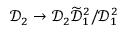Convert formula to latex. <formula><loc_0><loc_0><loc_500><loc_500>\mathcal { D } _ { 2 } \to \mathcal { D } _ { 2 } \widetilde { \mathcal { D } } _ { 1 } ^ { 2 } / \mathcal { D } _ { 1 } ^ { 2 }</formula> 